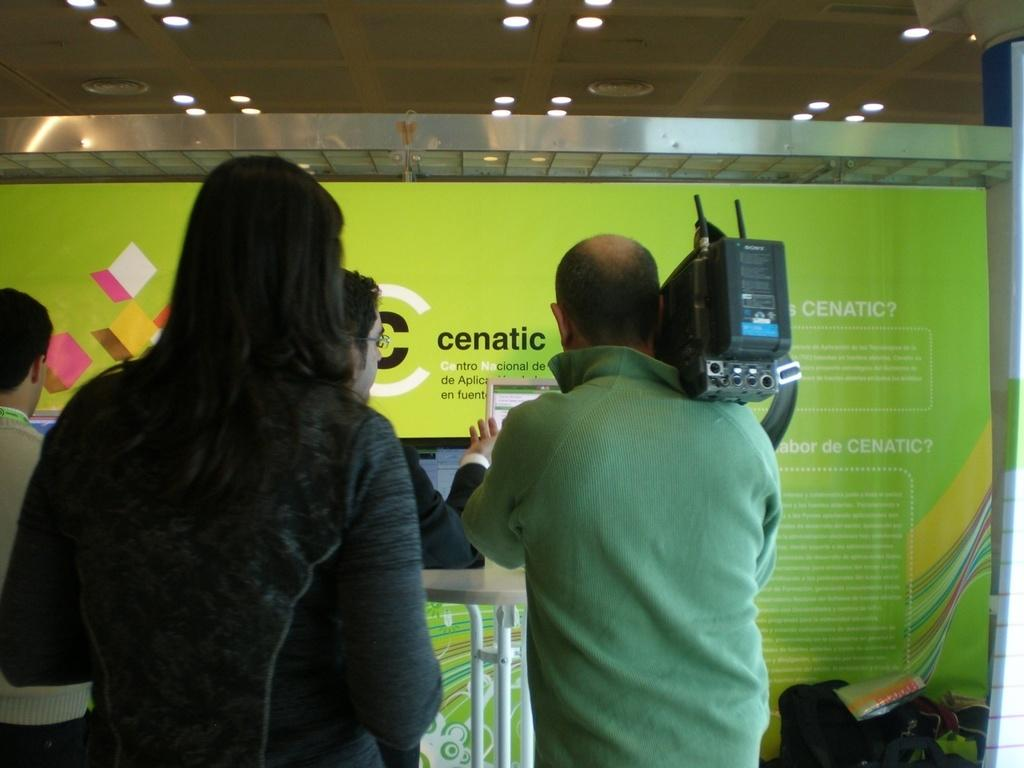What is happening in the image? There are people standing in the image. Can you describe what one of the people is doing? A person on the right is holding a camera. What objects can be seen on the table in the image? There are screens on a table in the image. What is located at the back of the image? There is a banner at the back in the image. What is visible at the top of the image? The sky is visible at the top of the image. What type of stove is being used by the police in the image? There is no stove or police present in the image. What day of the week is it in the image? The day of the week is not mentioned or visible in the image. 